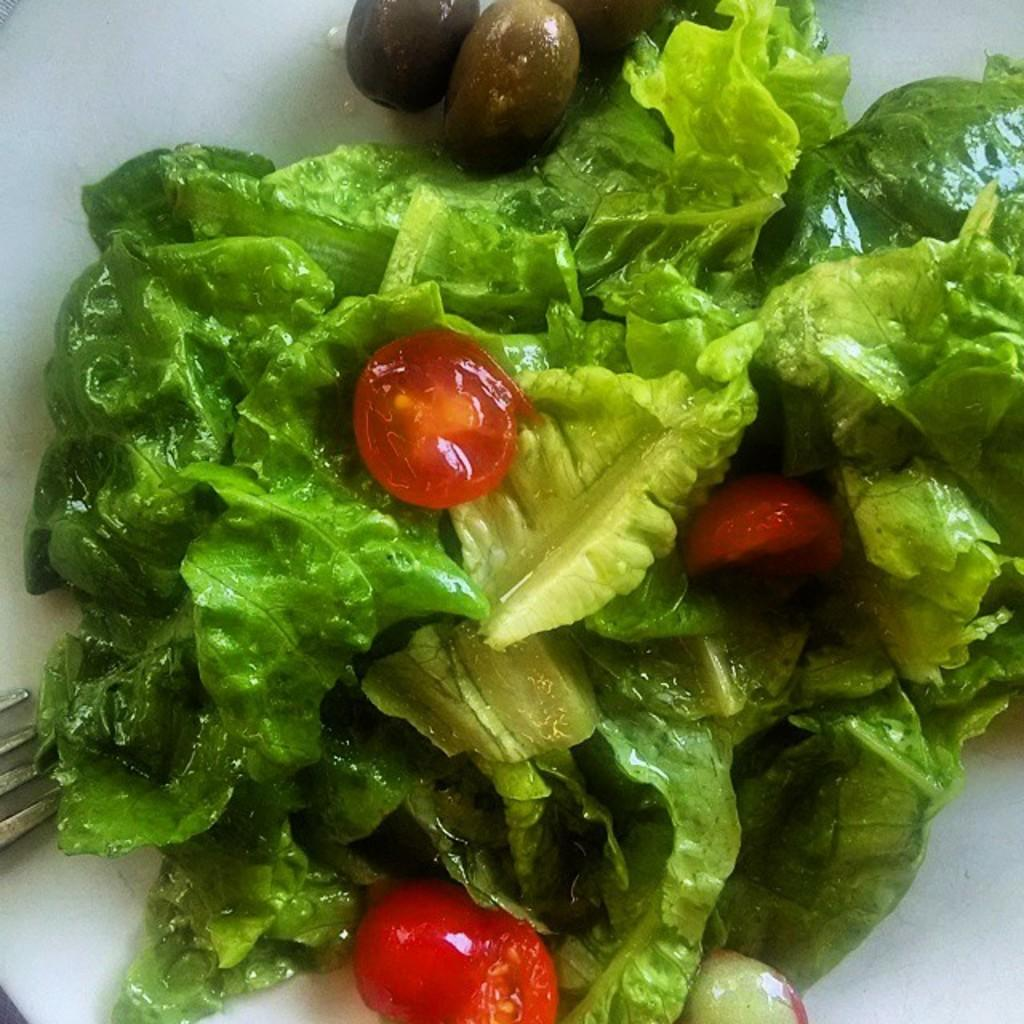What is present on the plate in the image? There are green leaves and vegetables on the plate in the image. Where is the fork located in the image? The fork is on the left side of the image. What type of machine is visible in the image? There is no machine present in the image. Can you describe the jar on the plate? There is no jar present on the plate in the image. 